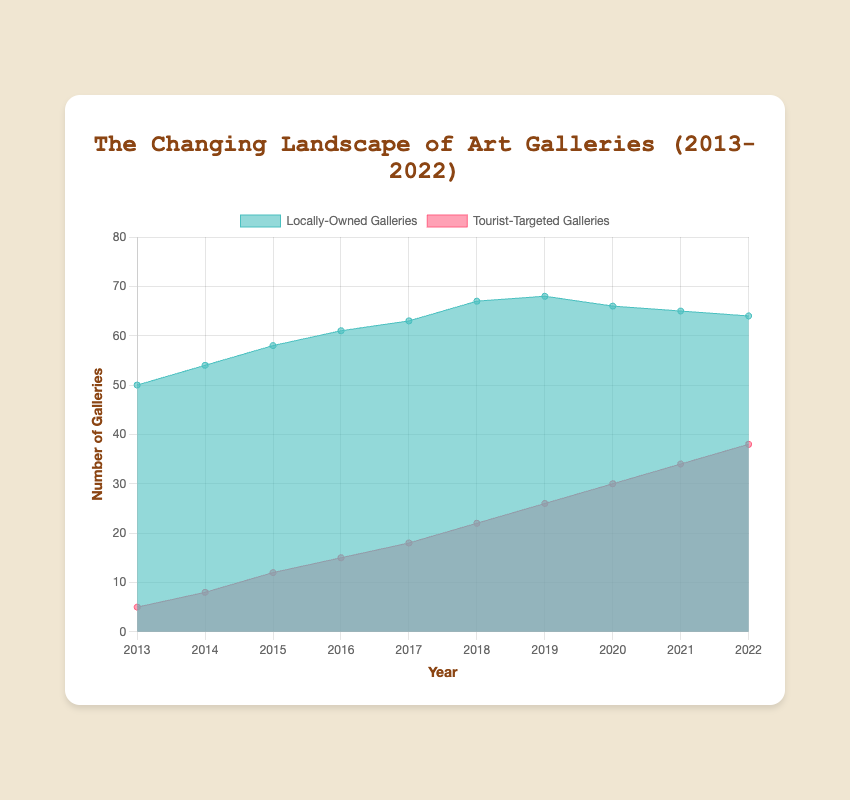What's the title of the chart? The title is placed at the top center part of the chart. It reads "The Changing Landscape of Art Galleries (2013-2022)".
Answer: The Changing Landscape of Art Galleries (2013-2022) How many locally-owned galleries were there in 2017? Locate the data point for locally-owned galleries in the year 2017. From the chart, we can see it corresponds to the y-value of 63.
Answer: 63 What is the general trend of tourist-targeted galleries from 2013 to 2022? Observing the area designated for tourist-targeted galleries, we see an increasing trend over the years from 5 in 2013 to 38 in 2022.
Answer: Increasing In which year did locally-owned galleries have the highest count? Examine the trend for locally-owned galleries. The highest count shown is in 2019 with a value of 68.
Answer: 2019 What is the difference in the number of tourist-targeted galleries between 2013 and 2022? Tourist-targeted galleries are shown as 5 in 2013 and 38 in 2022. The difference can be calculated by subtracting 5 from 38, which equals 33.
Answer: 33 Compare the number of locally-owned and tourist-targeted galleries in 2018. Which type was more prevalent? Refer to the year 2018 on the chart. Locally-owned galleries are at 67, while tourist-targeted are at 22. Locally-owned galleries are more prevalent as 67 > 22.
Answer: Locally-owned galleries What was the total number of galleries (both locally-owned and tourist-targeted) in 2020? Add the number of locally-owned galleries (66) to tourist-targeted galleries (30) in 2020. The sum is 66 + 30 = 96.
Answer: 96 How did the proportion of locally-owned galleries change from 2013 to 2022? In 2013 there were 50 locally-owned and 5 tourist-targeted, making 55 total galleries. Proportion of locally-owned in 2013 = 50/55 ≈ 91%. In 2022, there were 64 locally-owned and 38 tourist-targeted, total 102 galleries. Proportion of locally-owned in 2022 = 64/102 ≈ 63%. The proportion decreased.
Answer: Decreased By how much did the number of tourist-targeted galleries increase from 2017 to 2022? In 2017, tourist-targeted galleries were 18, and in 2022, they were 38. The increase is calculated by the difference, 38 - 18 = 20.
Answer: 20 At what year does the number of tourist-targeted galleries start to show a more significant increase compared to previous years? By inspecting the chart, a significant jump in numbers is observed between 2017 (18) and 2018 (22).
Answer: 2017 